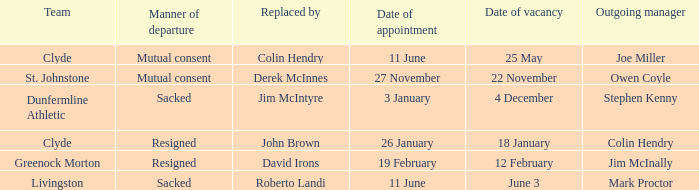Tell me the outgoing manager for livingston Mark Proctor. 